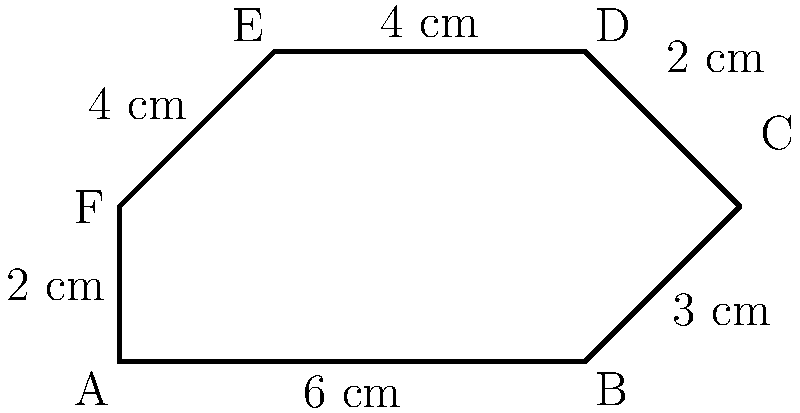A vegan restaurant is introducing a new irregularly shaped salad plate to showcase their plant-based creations. The plate's shape is represented by the hexagon ABCDEF in the diagram. Given the measurements shown, what is the perimeter of this unique salad plate in centimeters? To find the perimeter of the irregularly shaped salad plate, we need to sum up the lengths of all sides:

1. Side AB: 6 cm
2. Side BC: 3 cm
3. Side CD: 2 cm
4. Side DE: 4 cm
5. Side EF: 4 cm
6. Side FA: 2 cm

Now, let's add all these lengths:

$$\text{Perimeter} = 6 + 3 + 2 + 4 + 4 + 2 = 21 \text{ cm}$$

Therefore, the perimeter of the irregularly shaped salad plate is 21 cm.
Answer: 21 cm 